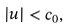Convert formula to latex. <formula><loc_0><loc_0><loc_500><loc_500>| u | < c _ { 0 } ,</formula> 